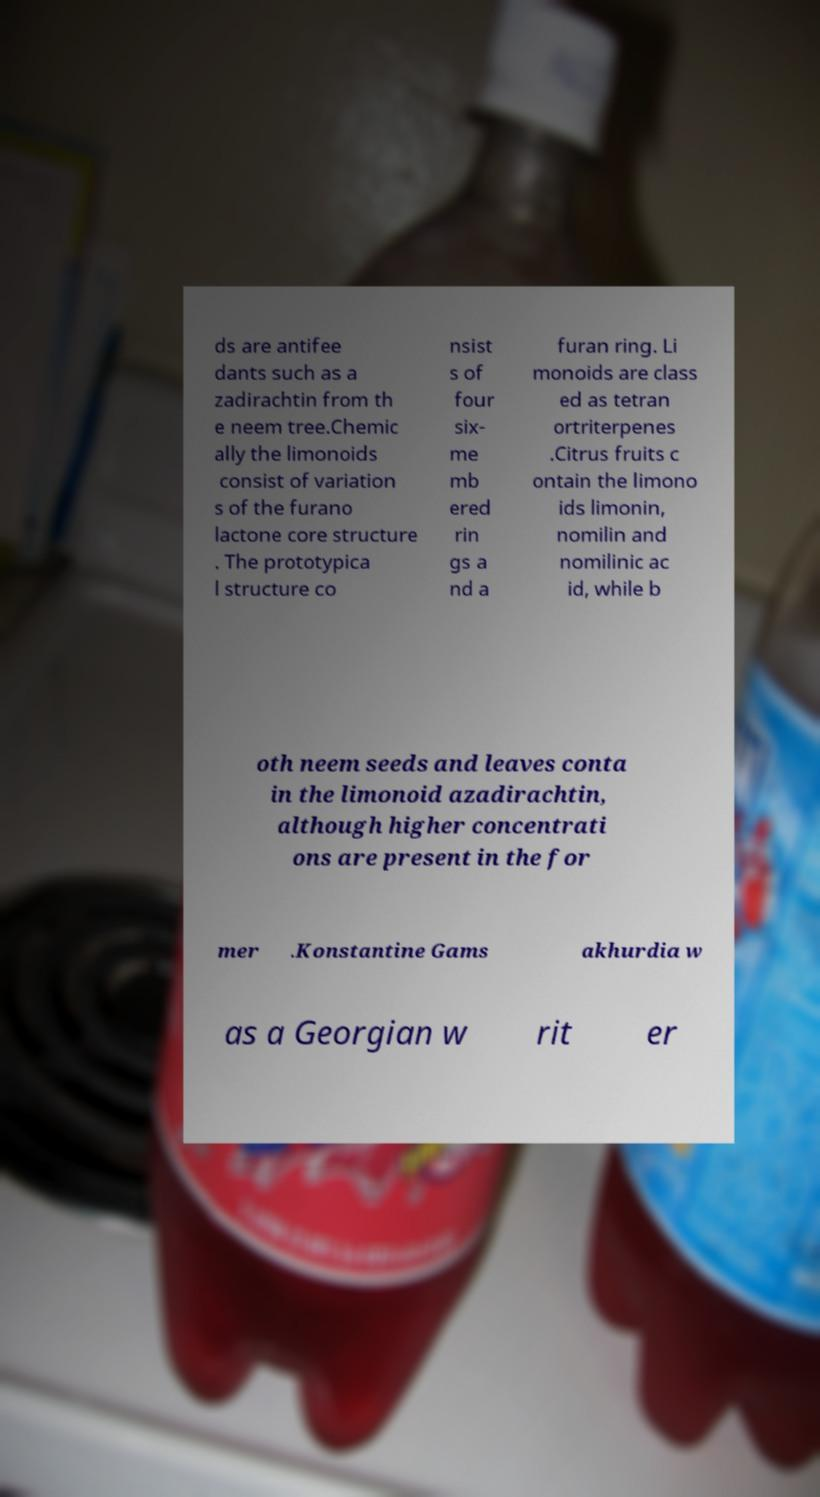Could you extract and type out the text from this image? ds are antifee dants such as a zadirachtin from th e neem tree.Chemic ally the limonoids consist of variation s of the furano lactone core structure . The prototypica l structure co nsist s of four six- me mb ered rin gs a nd a furan ring. Li monoids are class ed as tetran ortriterpenes .Citrus fruits c ontain the limono ids limonin, nomilin and nomilinic ac id, while b oth neem seeds and leaves conta in the limonoid azadirachtin, although higher concentrati ons are present in the for mer .Konstantine Gams akhurdia w as a Georgian w rit er 